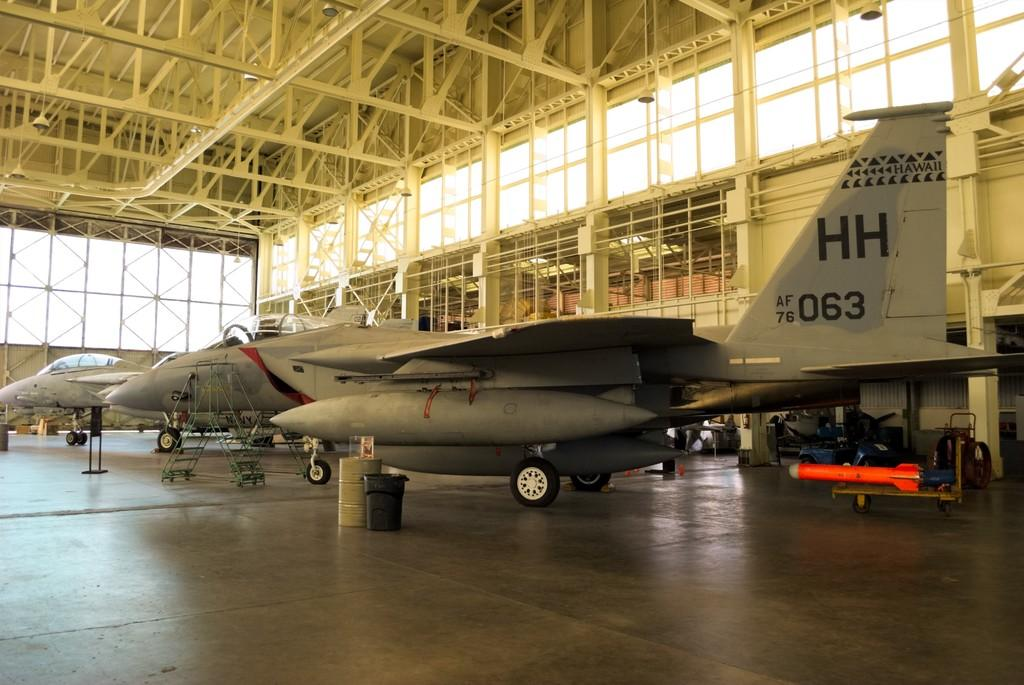What is the main subject in the center of the image? There are aeroplanes in the center of the image. What objects can be seen at the bottom of the image? There are bins at the bottom of the image. What can be seen in the background of the image? There are windows in the background of the image. What structure is visible at the top of the image? There is a roof at the top of the image. What type of ear is visible in the image? There is no ear present in the image. What idea is being conveyed by the aeroplanes in the image? The image does not convey any specific idea; it simply shows aeroplanes. 